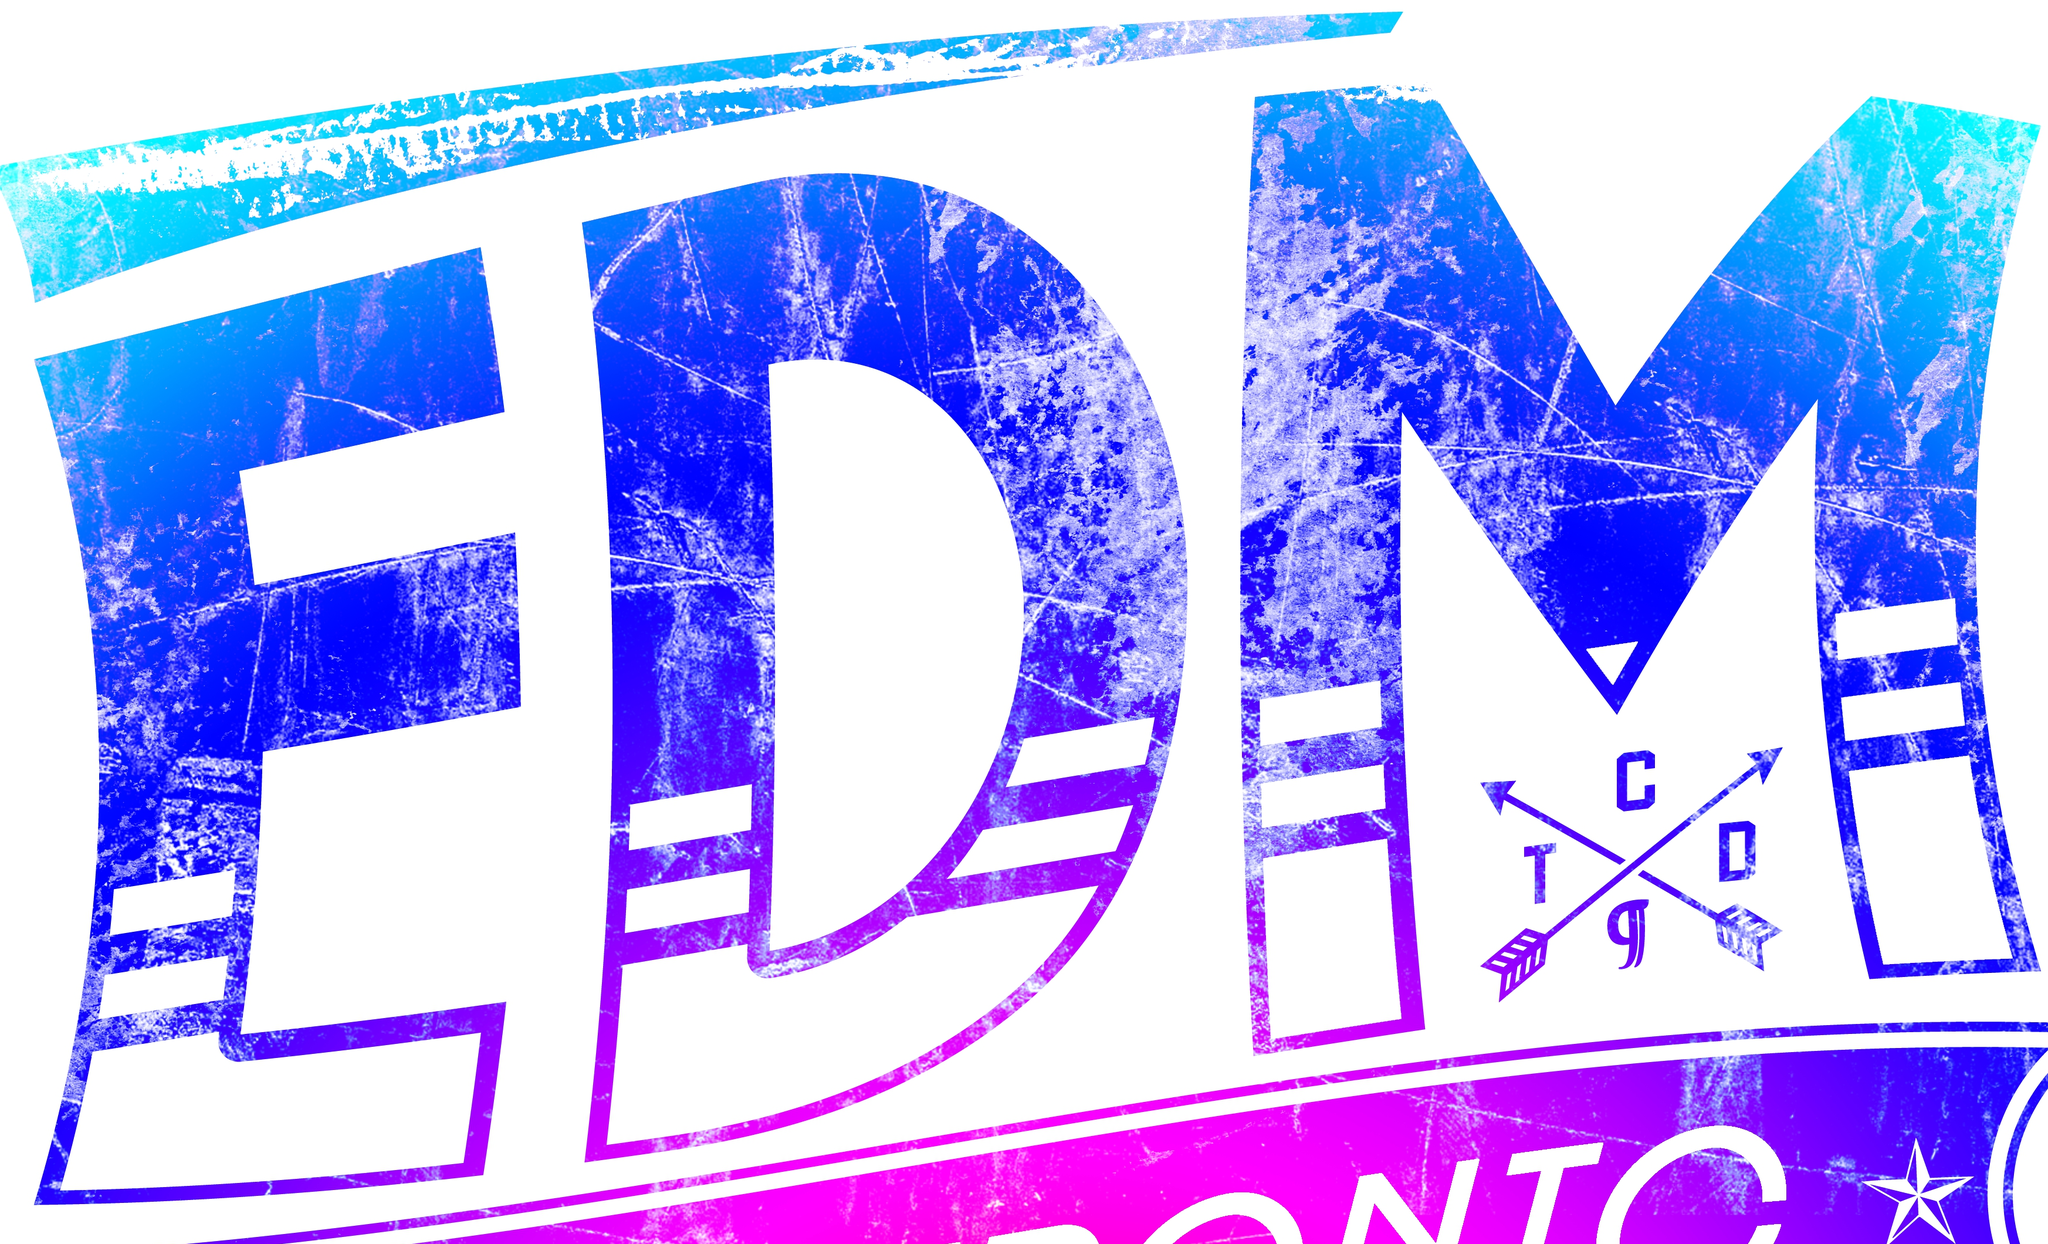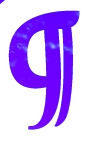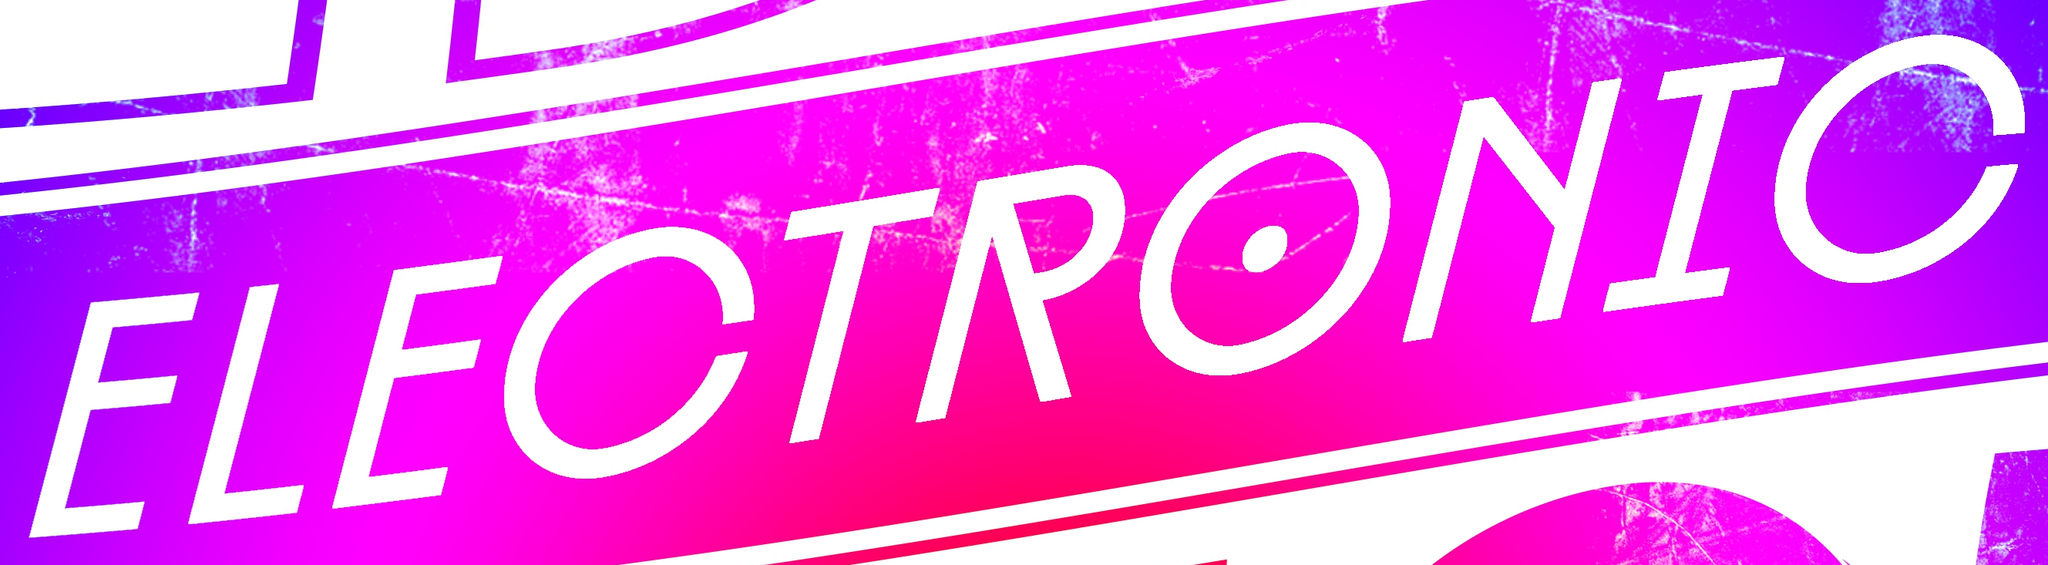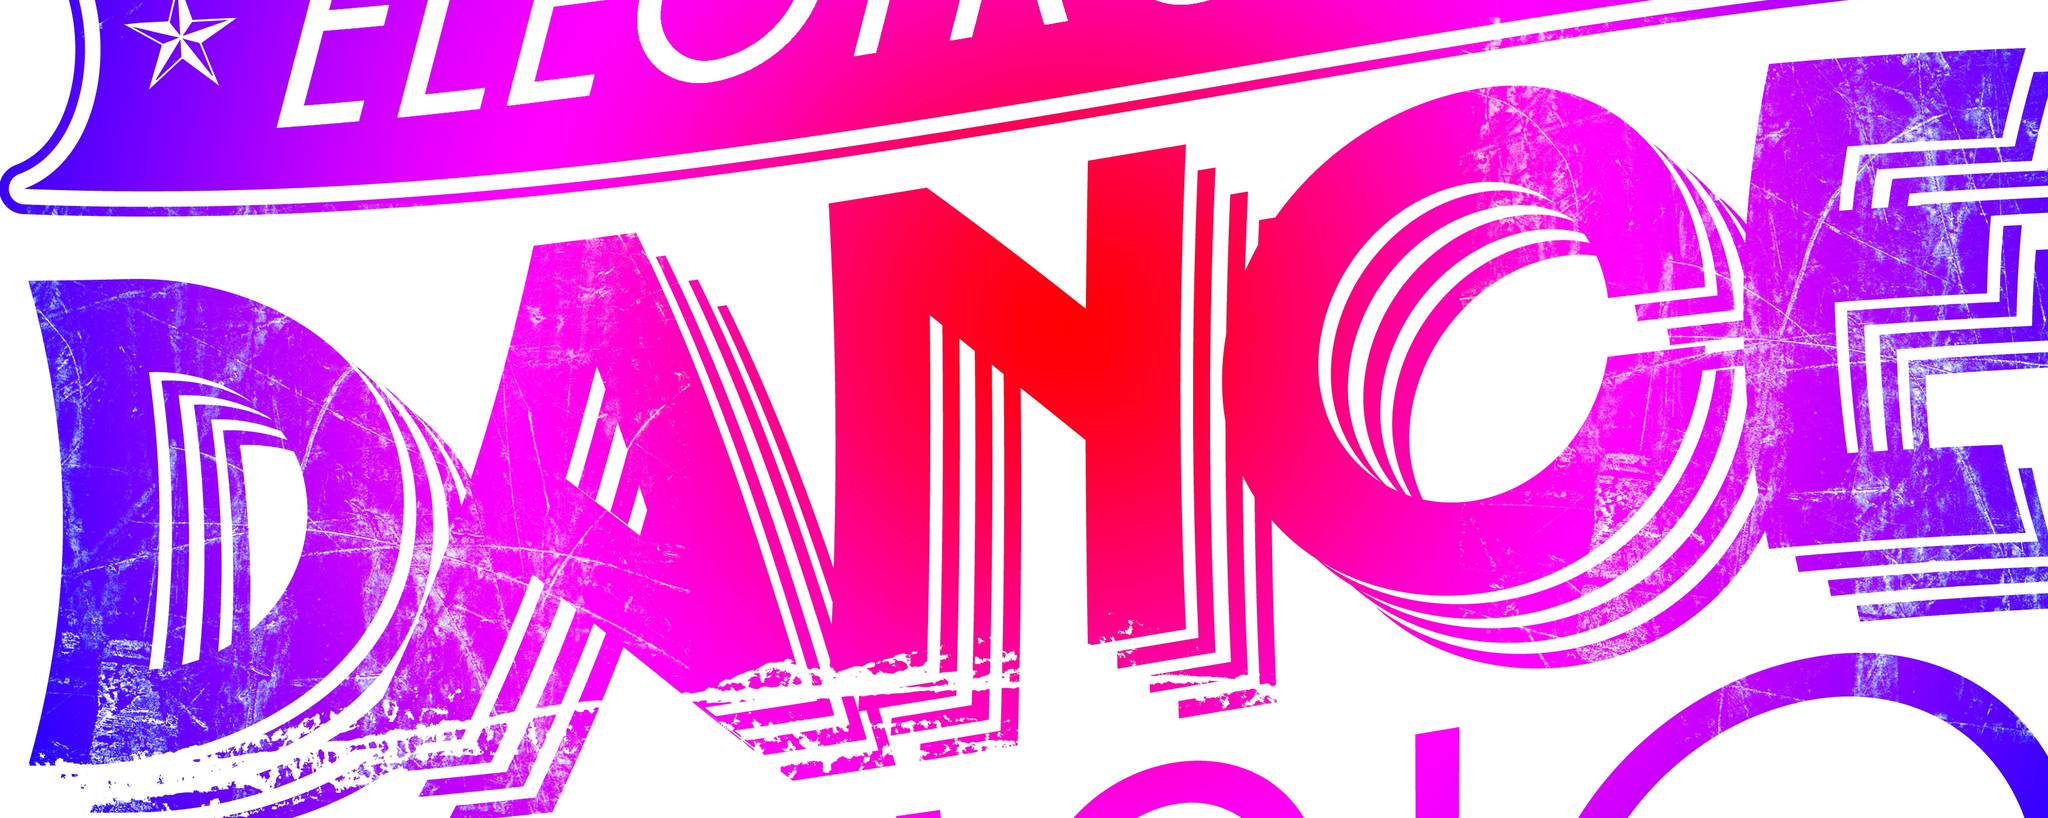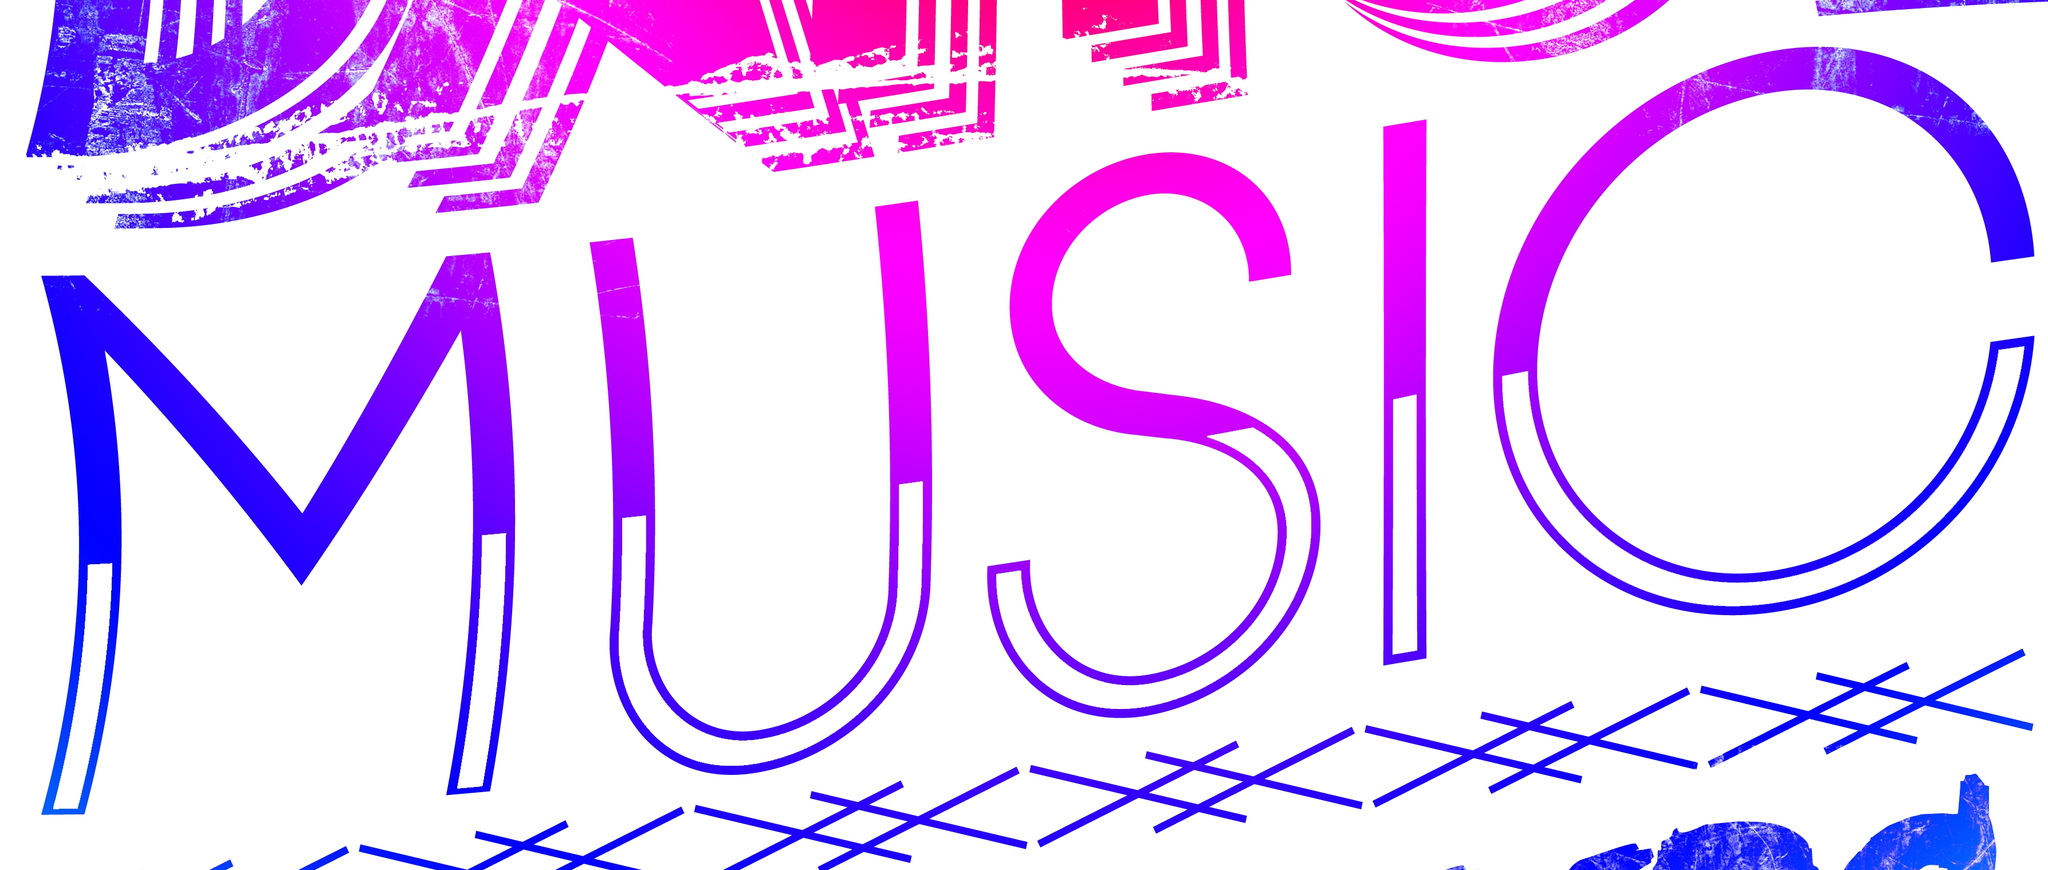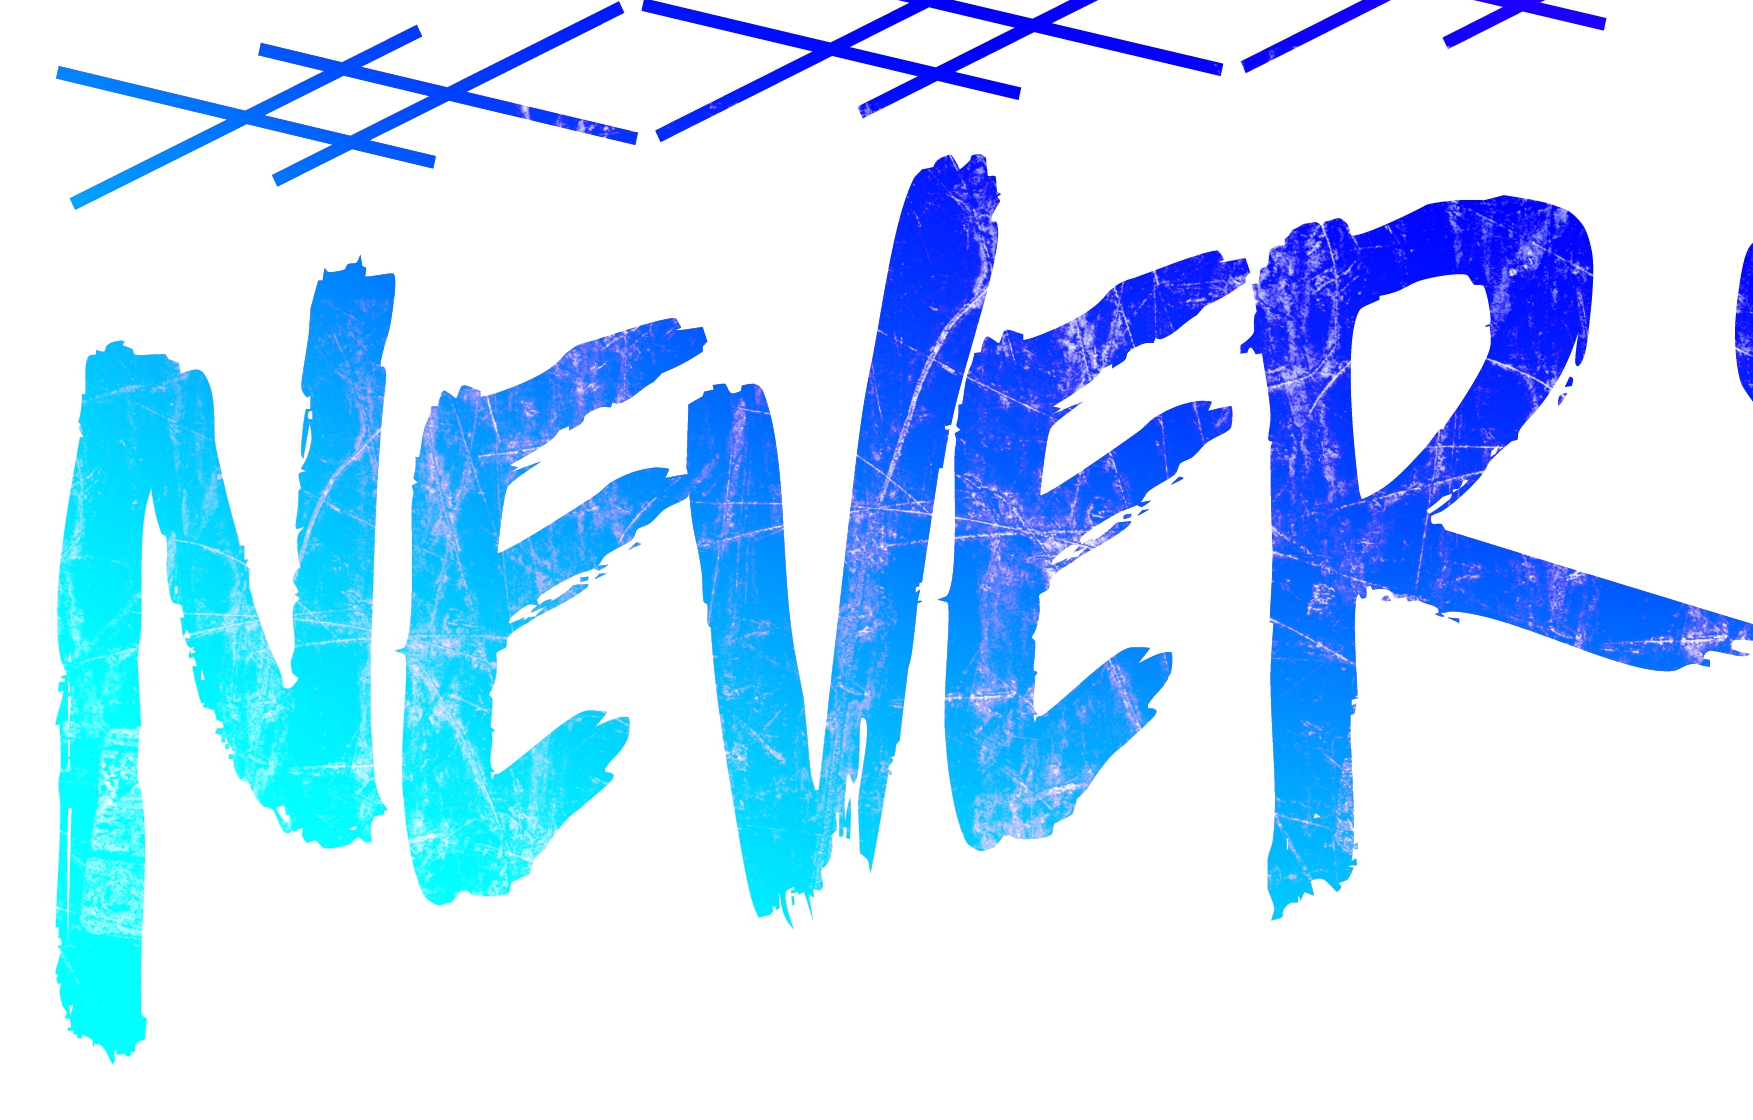Transcribe the words shown in these images in order, separated by a semicolon. EDM; g; ELECTRONIC; DANCE; MUSIC; NEVER 